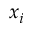Convert formula to latex. <formula><loc_0><loc_0><loc_500><loc_500>x _ { i }</formula> 